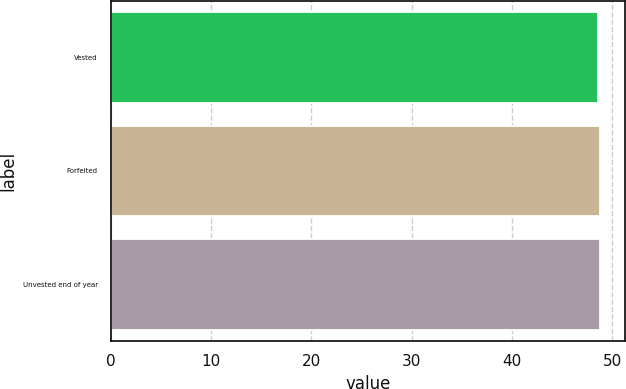<chart> <loc_0><loc_0><loc_500><loc_500><bar_chart><fcel>Vested<fcel>Forfeited<fcel>Unvested end of year<nl><fcel>48.56<fcel>48.78<fcel>48.82<nl></chart> 